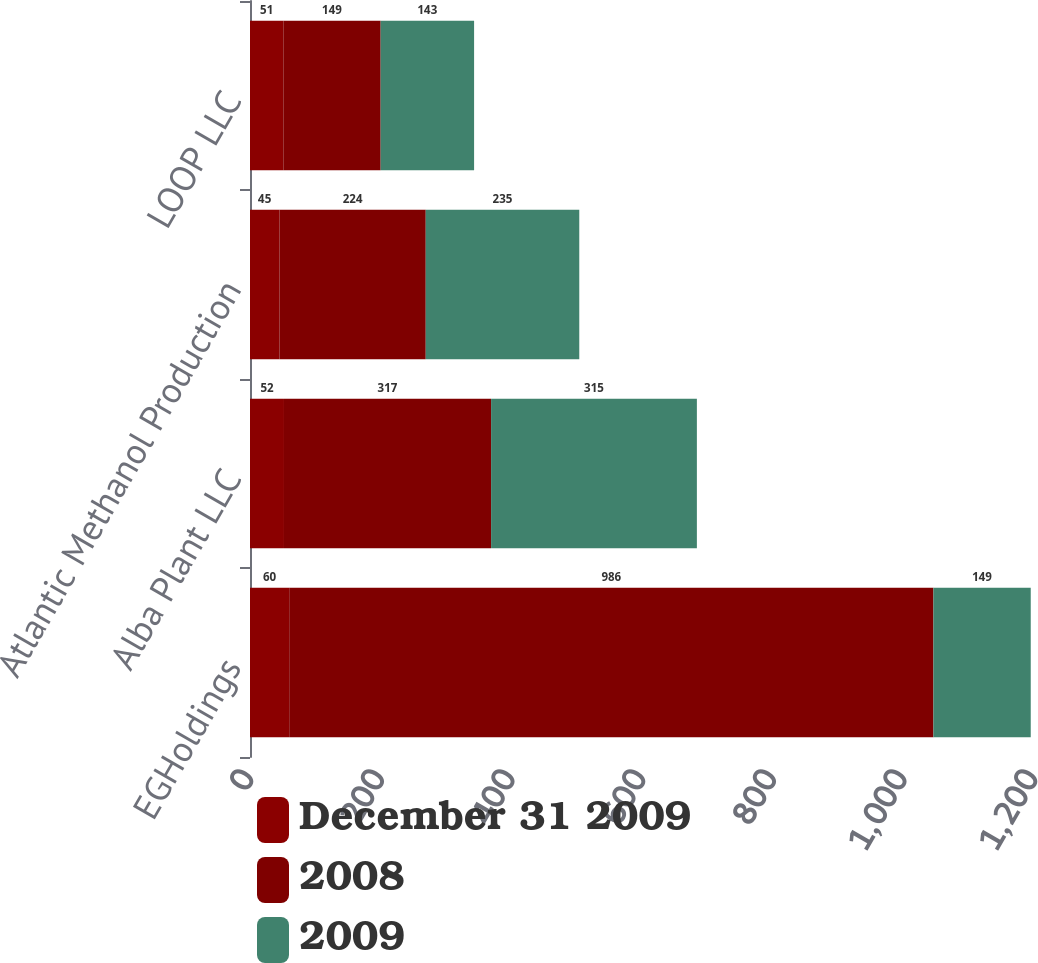<chart> <loc_0><loc_0><loc_500><loc_500><stacked_bar_chart><ecel><fcel>EGHoldings<fcel>Alba Plant LLC<fcel>Atlantic Methanol Production<fcel>LOOP LLC<nl><fcel>December 31 2009<fcel>60<fcel>52<fcel>45<fcel>51<nl><fcel>2008<fcel>986<fcel>317<fcel>224<fcel>149<nl><fcel>2009<fcel>149<fcel>315<fcel>235<fcel>143<nl></chart> 